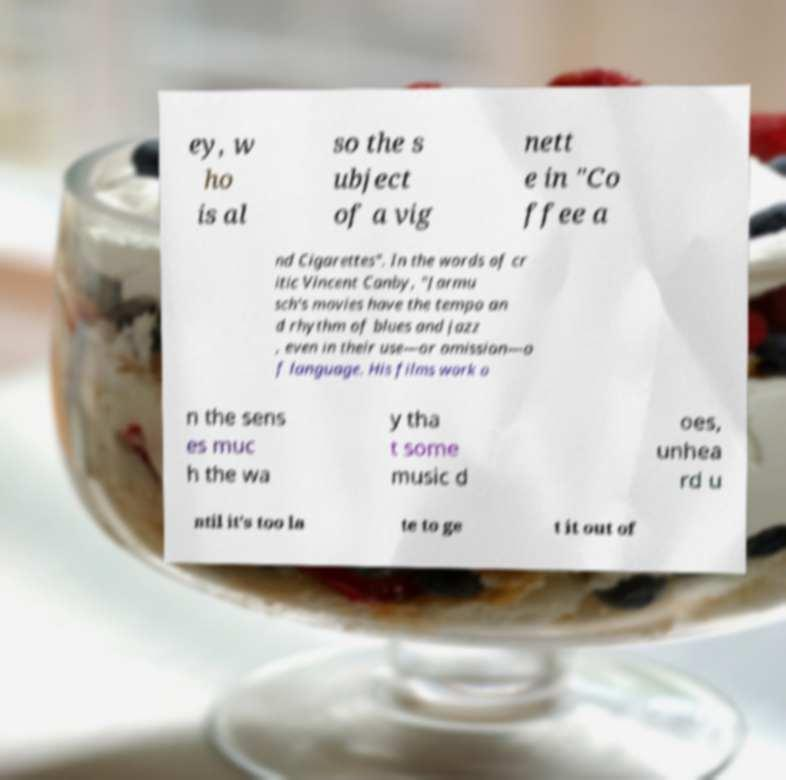For documentation purposes, I need the text within this image transcribed. Could you provide that? ey, w ho is al so the s ubject of a vig nett e in "Co ffee a nd Cigarettes". In the words of cr itic Vincent Canby, "Jarmu sch's movies have the tempo an d rhythm of blues and jazz , even in their use—or omission—o f language. His films work o n the sens es muc h the wa y tha t some music d oes, unhea rd u ntil it's too la te to ge t it out of 